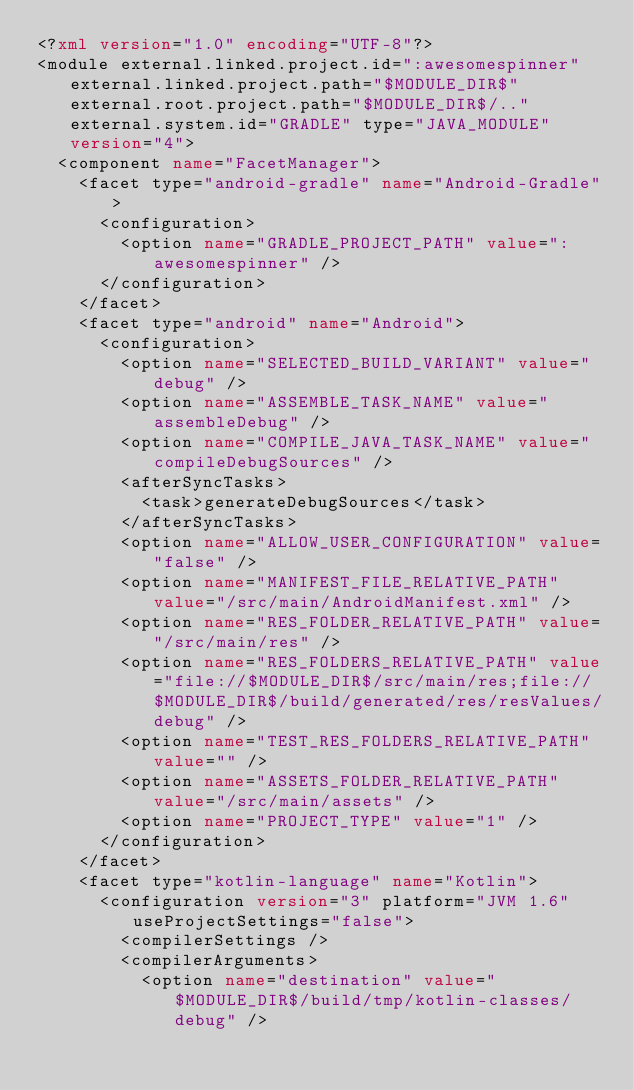<code> <loc_0><loc_0><loc_500><loc_500><_XML_><?xml version="1.0" encoding="UTF-8"?>
<module external.linked.project.id=":awesomespinner" external.linked.project.path="$MODULE_DIR$" external.root.project.path="$MODULE_DIR$/.." external.system.id="GRADLE" type="JAVA_MODULE" version="4">
  <component name="FacetManager">
    <facet type="android-gradle" name="Android-Gradle">
      <configuration>
        <option name="GRADLE_PROJECT_PATH" value=":awesomespinner" />
      </configuration>
    </facet>
    <facet type="android" name="Android">
      <configuration>
        <option name="SELECTED_BUILD_VARIANT" value="debug" />
        <option name="ASSEMBLE_TASK_NAME" value="assembleDebug" />
        <option name="COMPILE_JAVA_TASK_NAME" value="compileDebugSources" />
        <afterSyncTasks>
          <task>generateDebugSources</task>
        </afterSyncTasks>
        <option name="ALLOW_USER_CONFIGURATION" value="false" />
        <option name="MANIFEST_FILE_RELATIVE_PATH" value="/src/main/AndroidManifest.xml" />
        <option name="RES_FOLDER_RELATIVE_PATH" value="/src/main/res" />
        <option name="RES_FOLDERS_RELATIVE_PATH" value="file://$MODULE_DIR$/src/main/res;file://$MODULE_DIR$/build/generated/res/resValues/debug" />
        <option name="TEST_RES_FOLDERS_RELATIVE_PATH" value="" />
        <option name="ASSETS_FOLDER_RELATIVE_PATH" value="/src/main/assets" />
        <option name="PROJECT_TYPE" value="1" />
      </configuration>
    </facet>
    <facet type="kotlin-language" name="Kotlin">
      <configuration version="3" platform="JVM 1.6" useProjectSettings="false">
        <compilerSettings />
        <compilerArguments>
          <option name="destination" value="$MODULE_DIR$/build/tmp/kotlin-classes/debug" /></code> 